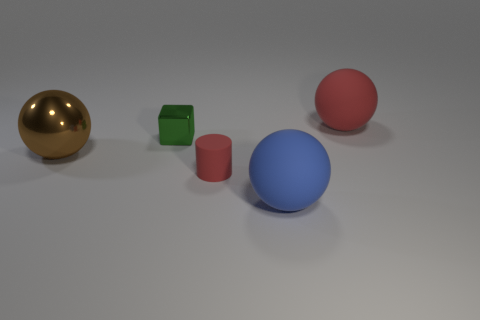The red cylinder that is made of the same material as the big red ball is what size?
Keep it short and to the point. Small. Is the color of the big shiny thing the same as the large matte ball that is left of the large red matte thing?
Ensure brevity in your answer.  No. What material is the thing that is both behind the large brown shiny ball and left of the large blue matte thing?
Your response must be concise. Metal. The matte object that is the same color as the small cylinder is what size?
Provide a short and direct response. Large. There is a large matte thing that is on the right side of the large blue matte ball; is it the same shape as the large rubber object in front of the cube?
Offer a terse response. Yes. Is there a big object?
Your answer should be very brief. Yes. There is another large matte thing that is the same shape as the large red object; what is its color?
Provide a short and direct response. Blue. What is the color of the cube that is the same size as the matte cylinder?
Provide a succinct answer. Green. Do the big red thing and the small green thing have the same material?
Make the answer very short. No. How many tiny rubber objects are the same color as the small cube?
Provide a short and direct response. 0. 